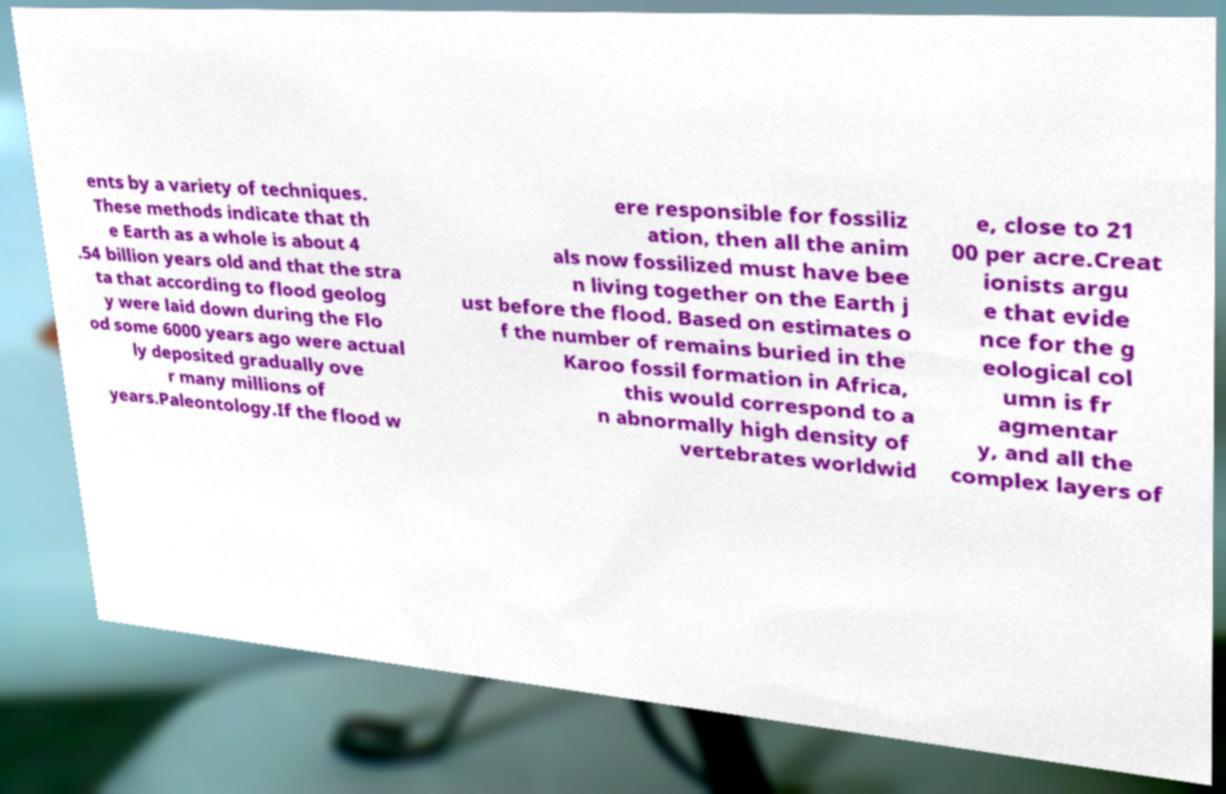Please identify and transcribe the text found in this image. ents by a variety of techniques. These methods indicate that th e Earth as a whole is about 4 .54 billion years old and that the stra ta that according to flood geolog y were laid down during the Flo od some 6000 years ago were actual ly deposited gradually ove r many millions of years.Paleontology.If the flood w ere responsible for fossiliz ation, then all the anim als now fossilized must have bee n living together on the Earth j ust before the flood. Based on estimates o f the number of remains buried in the Karoo fossil formation in Africa, this would correspond to a n abnormally high density of vertebrates worldwid e, close to 21 00 per acre.Creat ionists argu e that evide nce for the g eological col umn is fr agmentar y, and all the complex layers of 